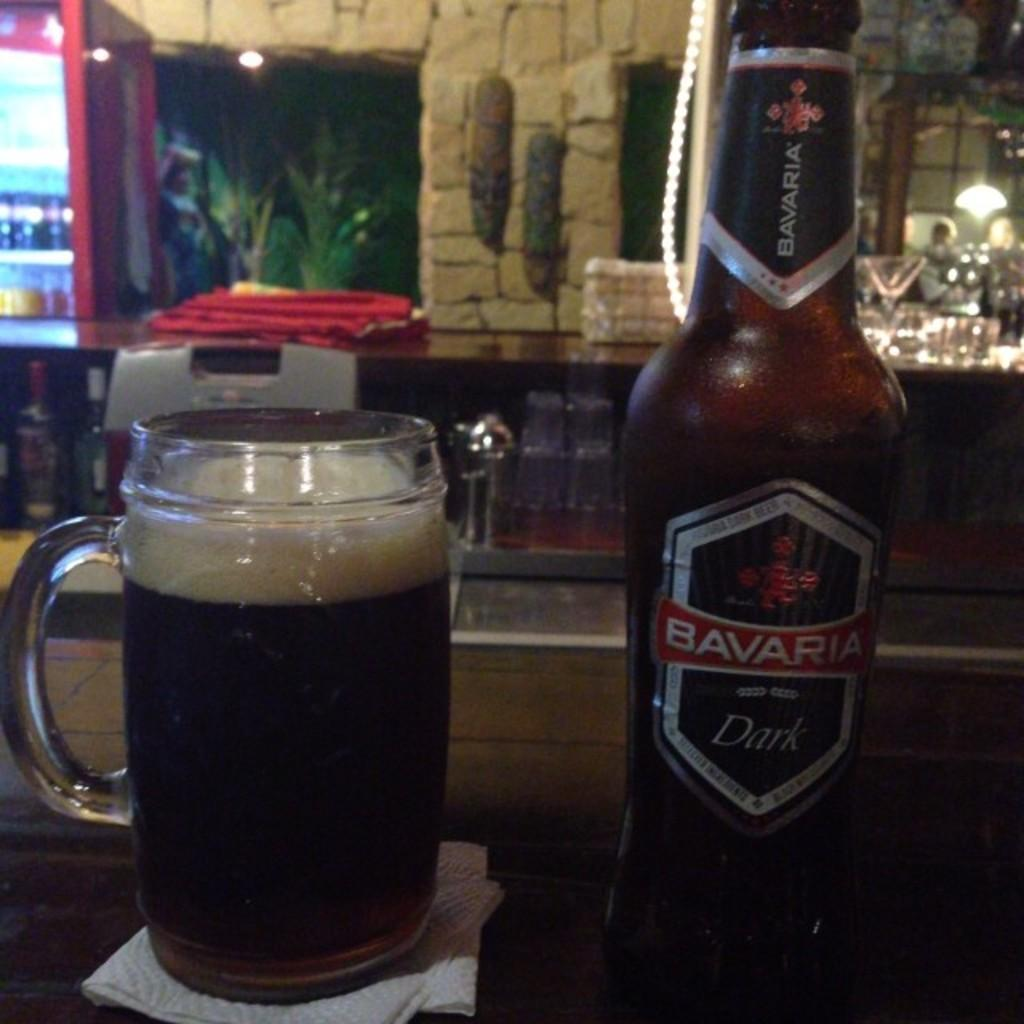<image>
Offer a succinct explanation of the picture presented. Bottle of alcohol that says "Bavaria" next to a cup. 